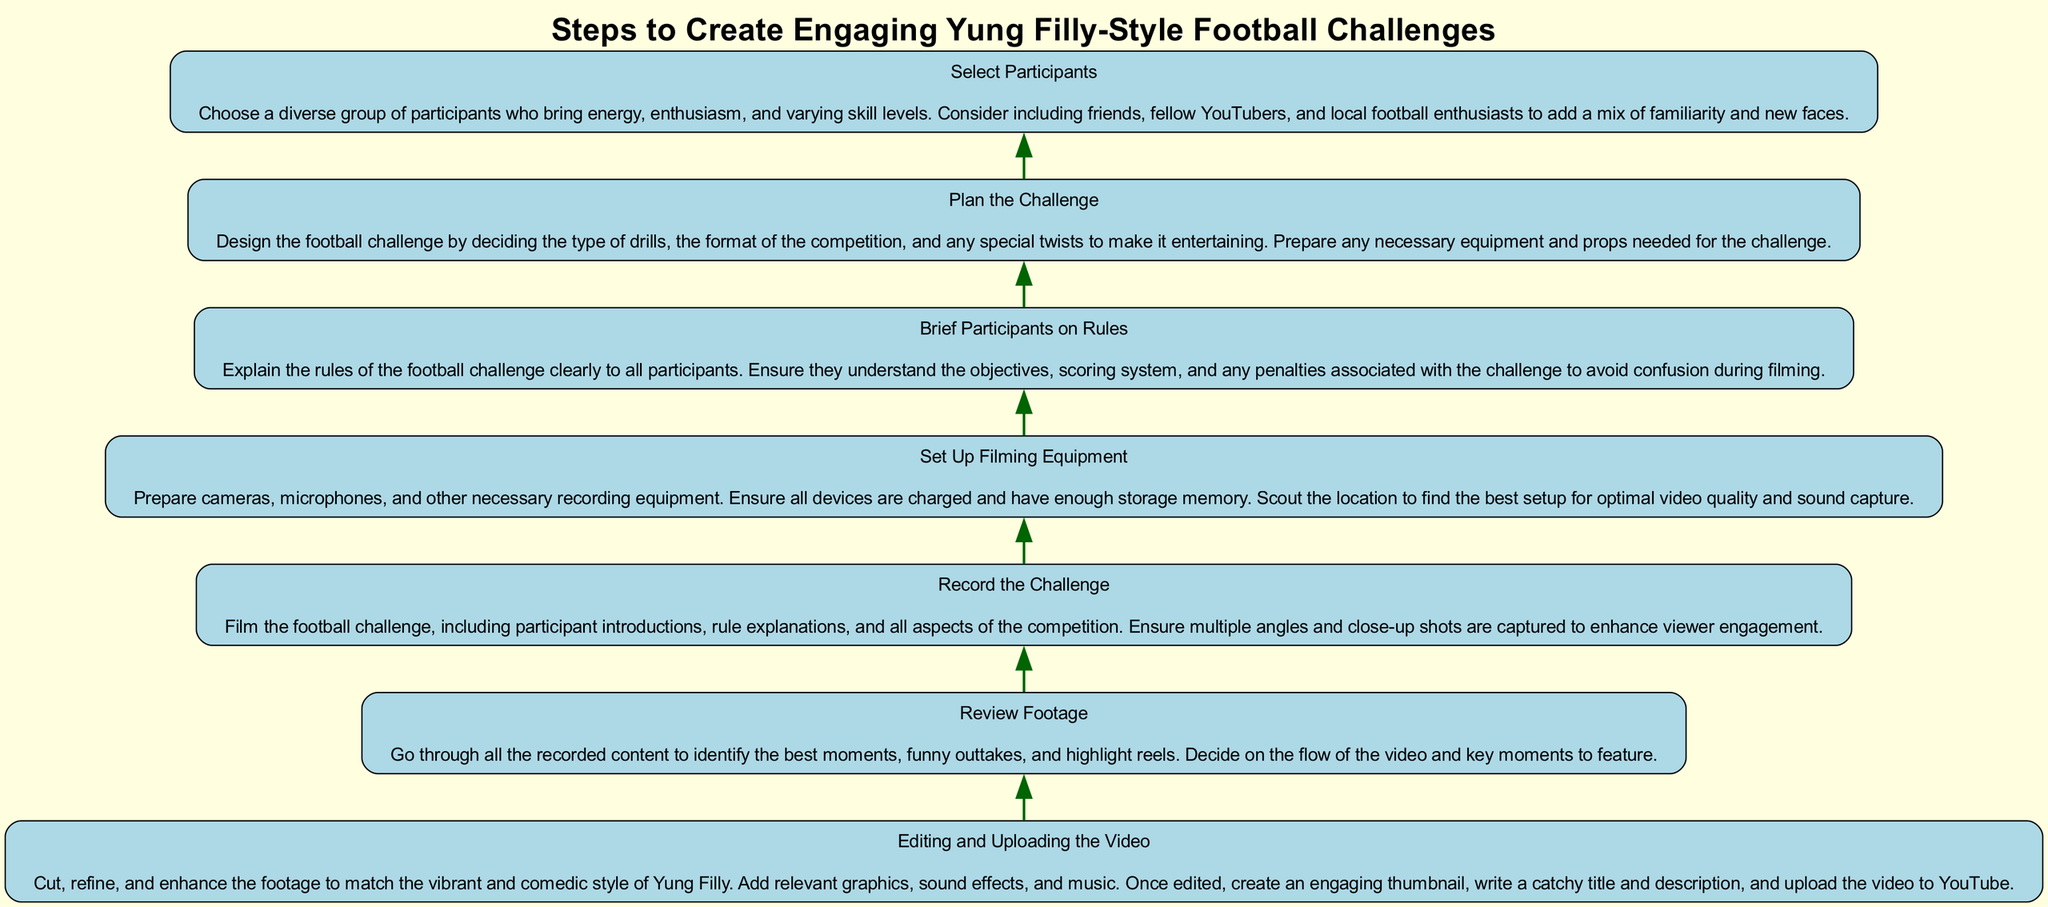What is the first step in the diagram? The first step is "Select Participants". This is the initial action taken before any other steps, as indicated by its position at the bottom of the flow chart.
Answer: Select Participants How many total steps are in the flow chart? There are a total of seven steps in the flow chart, as can be counted going upward from bottom to top.
Answer: Seven What is the last step outlined in the diagram? The last step is "Editing and Uploading the Video". This step concludes the flow, as it is positioned at the top of the chart.
Answer: Editing and Uploading the Video Which step comes immediately after "Plan the Challenge"? The step that comes immediately after "Plan the Challenge" is "Brief Participants on Rules". This is determined by the direct connection upwards from the planning step.
Answer: Brief Participants on Rules What action is required before capturing the challenge on video? The action required before recording the challenge is "Set Up Filming Equipment". This step must be completed to ensure proper recording conditions.
Answer: Set Up Filming Equipment Which two steps fall between "Select Participants" and "Editing and Uploading the Video"? The two steps are "Plan the Challenge" and "Record the Challenge". These steps sequentially follow "Select Participants" and precede the last step.
Answer: Plan the Challenge and Record the Challenge What is the purpose of "Review Footage" in the process? The purpose of "Review Footage" is to identify the best moments and decide on the flow of the video. This step helps in making the final edited version more engaging.
Answer: Identify best moments What type of content should be included during "Record the Challenge"? The content to be included during "Record the Challenge" should involve participant introductions, rule explanations, and various competition aspects. This ensures the video captures the necessary elements of the challenge.
Answer: Participant introductions, rule explanations, competition aspects What is emphasized in the description of "Brief Participants on Rules"? The emphasis is on ensuring that all participants understand the objectives, scoring system, and penalties of the challenge. This clarity avoids confusion during filming, which is vital for a smooth challenge.
Answer: Understanding objectives and scoring system 